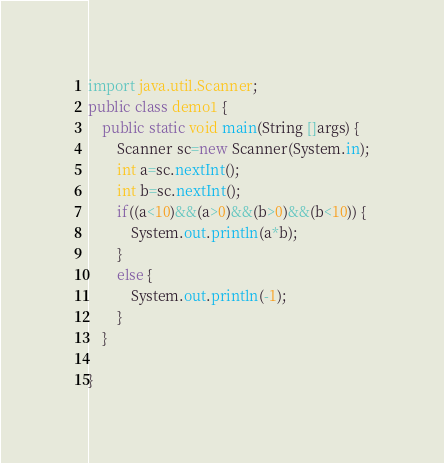Convert code to text. <code><loc_0><loc_0><loc_500><loc_500><_Java_>import java.util.Scanner;
public class demo1 {
	public static void main(String []args) {
		Scanner sc=new Scanner(System.in);
		int a=sc.nextInt();
		int b=sc.nextInt();
		if((a<10)&&(a>0)&&(b>0)&&(b<10)) {
			System.out.println(a*b);
		}
		else {
			System.out.println(-1);
		}
	}

}
</code> 